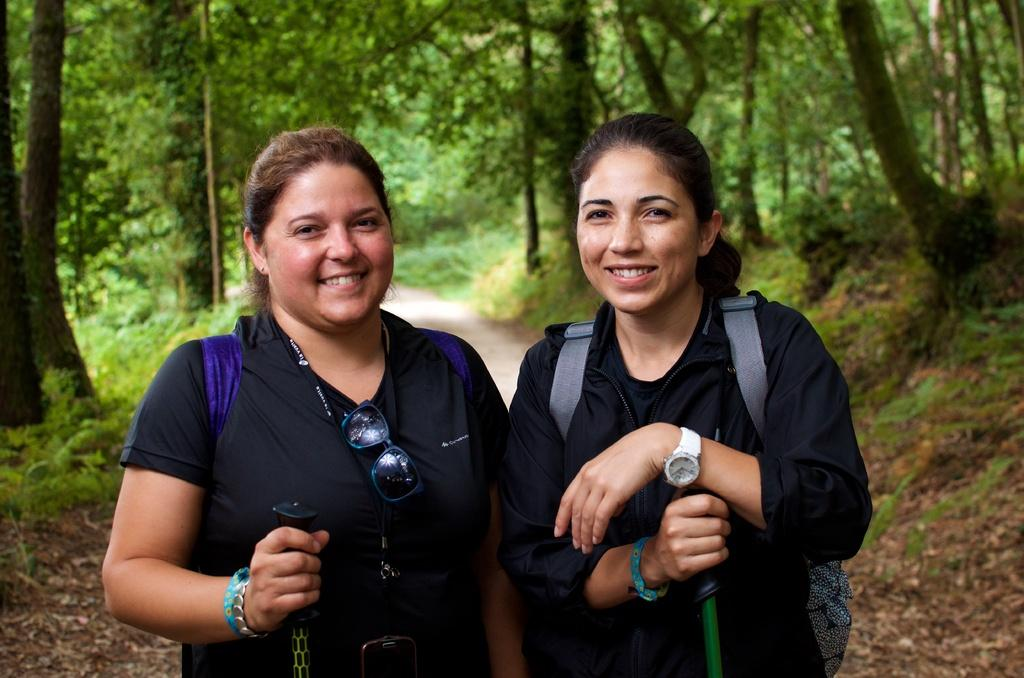How many people are in the image? There are two ladies in the image. What are the ladies doing in the image? The ladies are smiling in the image. What are the ladies holding in their hands? The ladies are holding a stick in their hands. What can be seen in the background of the image? There are trees in the background of the image. How many jellyfish can be seen swimming near the ladies in the image? There are no jellyfish present in the image. What finger is the lady on the left pointing with in the image? The image does not show the ladies pointing with their fingers. 